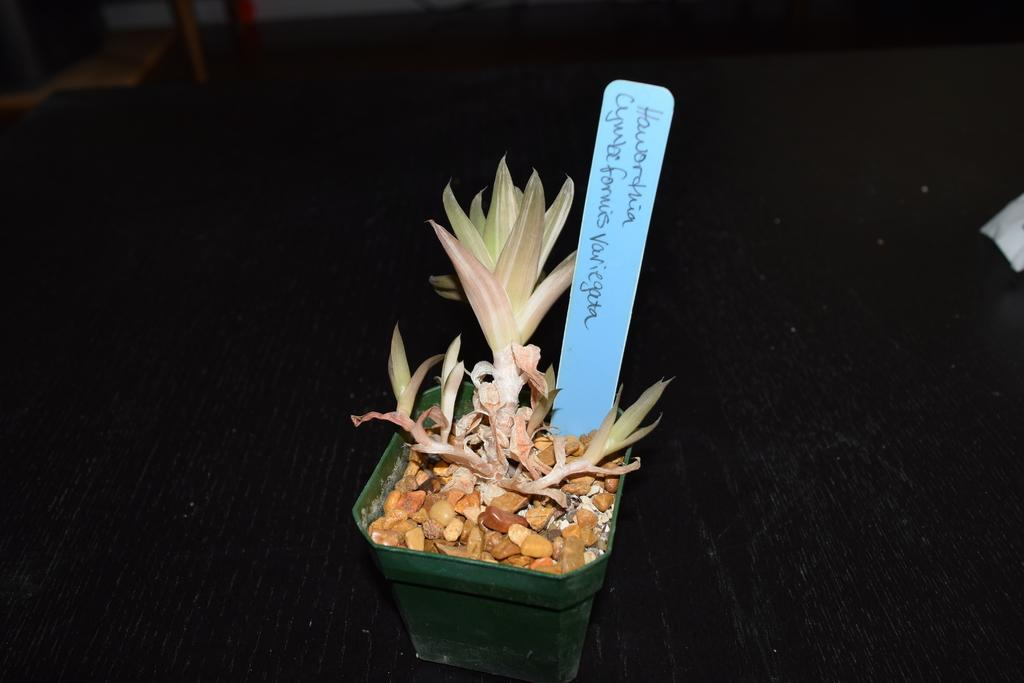What type of plant is in the image? There is a plant in a pot in the image. What else can be seen related to the plant? There are objects associated with the plant. What is written or displayed on a board in the image? There is a board with text in the image. How would you describe the overall lighting or brightness in the image? The background of the image is dark. How deep is the quicksand surrounding the plant in the image? There is no quicksand present in the image; it features a plant in a pot with associated objects and a board with text. 